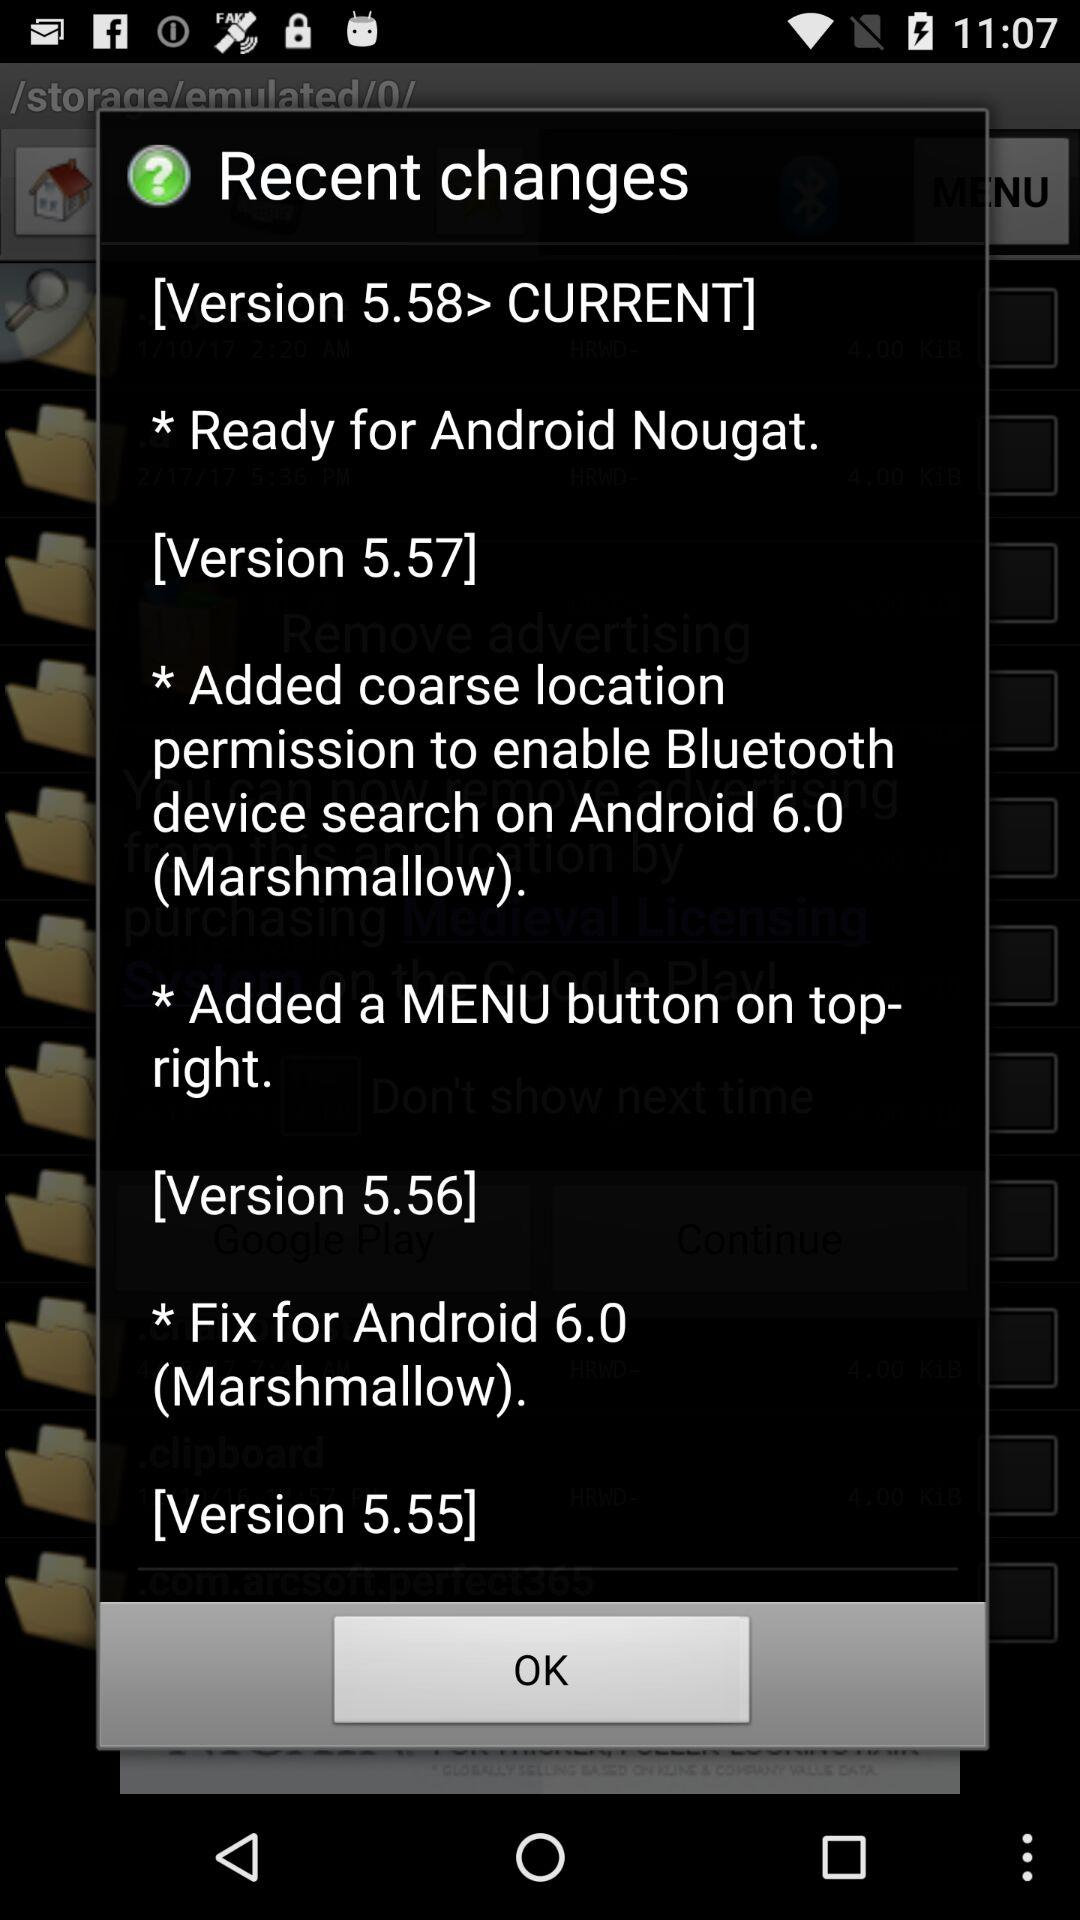What's the current version? The current version is 5.58. 